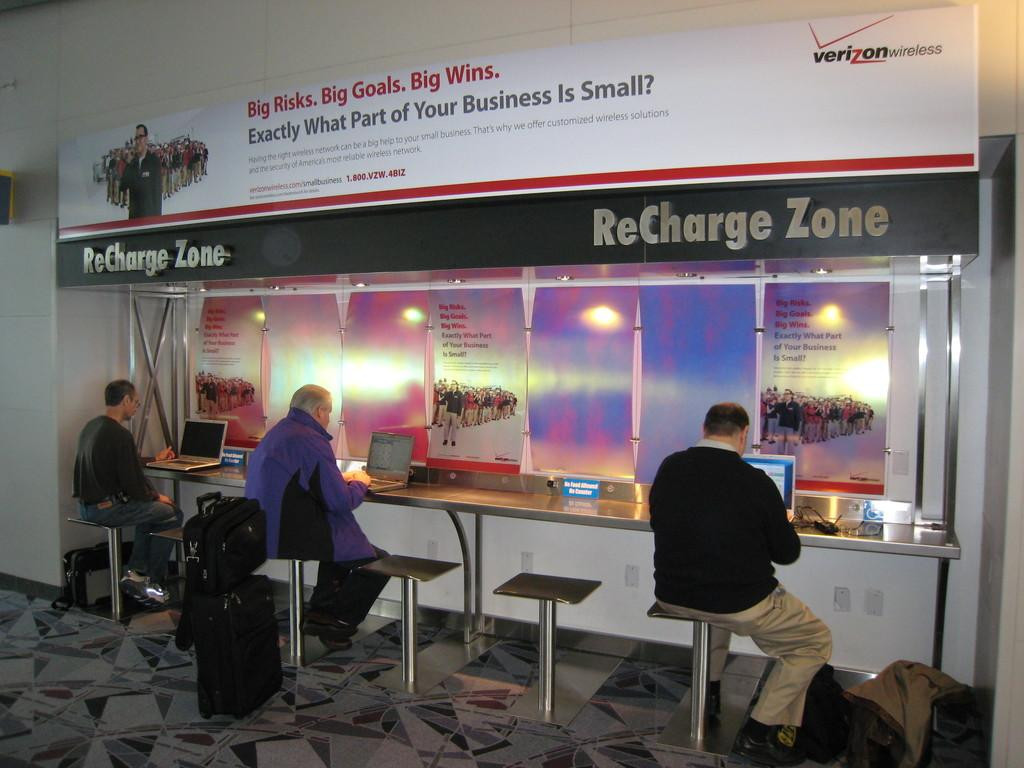<image>
Describe the image concisely. Three travelers are sitting at a ReCharge Zone sponsored by Verizon. 